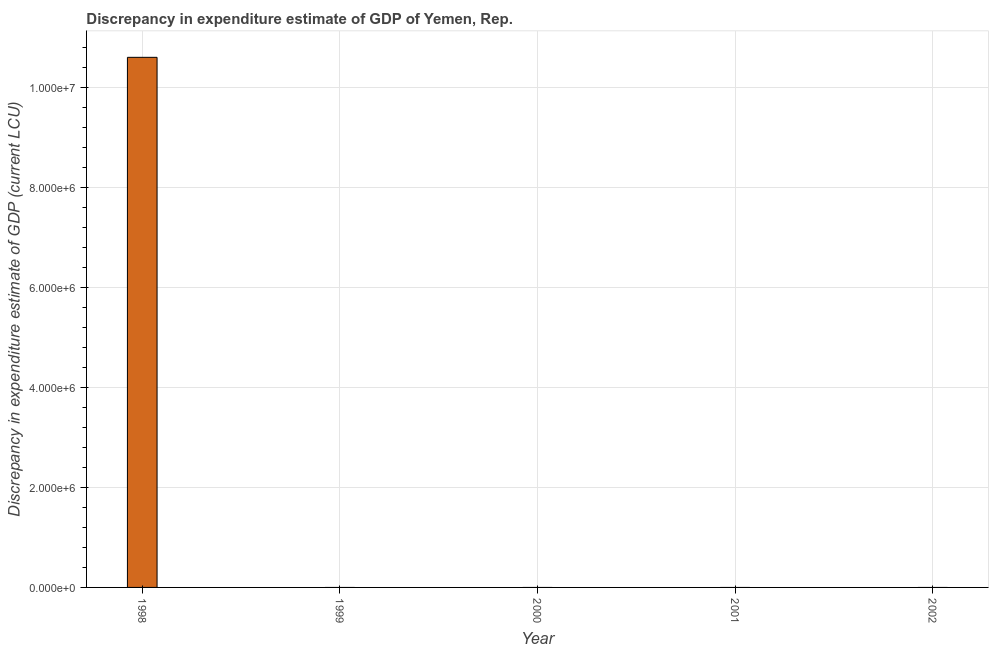Does the graph contain grids?
Provide a short and direct response. Yes. What is the title of the graph?
Provide a short and direct response. Discrepancy in expenditure estimate of GDP of Yemen, Rep. What is the label or title of the Y-axis?
Give a very brief answer. Discrepancy in expenditure estimate of GDP (current LCU). Across all years, what is the maximum discrepancy in expenditure estimate of gdp?
Ensure brevity in your answer.  1.06e+07. What is the sum of the discrepancy in expenditure estimate of gdp?
Provide a short and direct response. 1.06e+07. What is the average discrepancy in expenditure estimate of gdp per year?
Ensure brevity in your answer.  2.12e+06. What is the median discrepancy in expenditure estimate of gdp?
Provide a succinct answer. 0. What is the difference between the highest and the lowest discrepancy in expenditure estimate of gdp?
Your answer should be very brief. 1.06e+07. Are all the bars in the graph horizontal?
Give a very brief answer. No. What is the Discrepancy in expenditure estimate of GDP (current LCU) of 1998?
Your response must be concise. 1.06e+07. What is the Discrepancy in expenditure estimate of GDP (current LCU) of 1999?
Provide a short and direct response. 0. What is the Discrepancy in expenditure estimate of GDP (current LCU) in 2001?
Ensure brevity in your answer.  0. What is the Discrepancy in expenditure estimate of GDP (current LCU) in 2002?
Offer a very short reply. 0. 